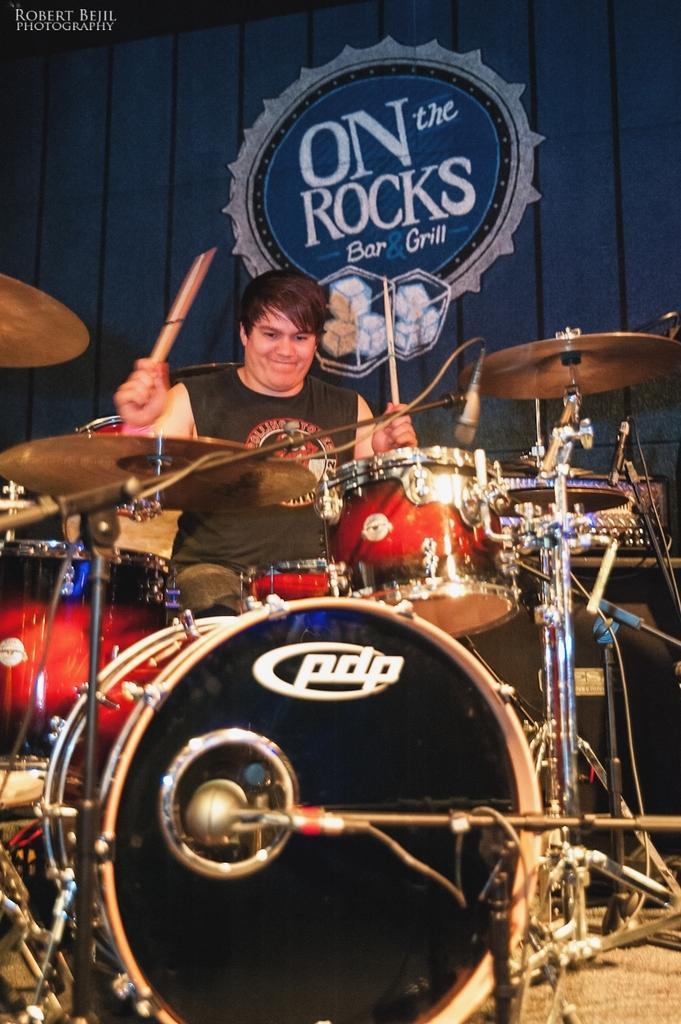Please provide a concise description of this image. In this image I can see a person is holding sticks. In-front of that person there are musical instruments. At the top left side of the image there is a watermark. In the background of the image there is a wall and board. 